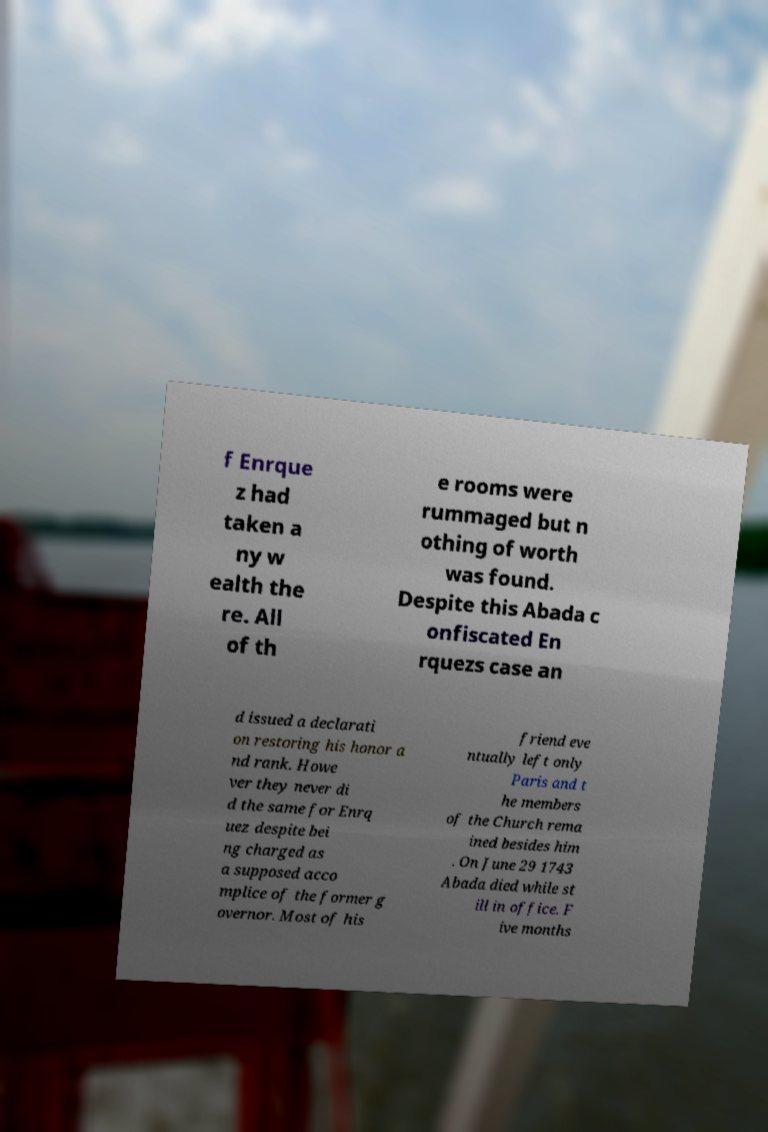Can you accurately transcribe the text from the provided image for me? f Enrque z had taken a ny w ealth the re. All of th e rooms were rummaged but n othing of worth was found. Despite this Abada c onfiscated En rquezs case an d issued a declarati on restoring his honor a nd rank. Howe ver they never di d the same for Enrq uez despite bei ng charged as a supposed acco mplice of the former g overnor. Most of his friend eve ntually left only Paris and t he members of the Church rema ined besides him . On June 29 1743 Abada died while st ill in office. F ive months 